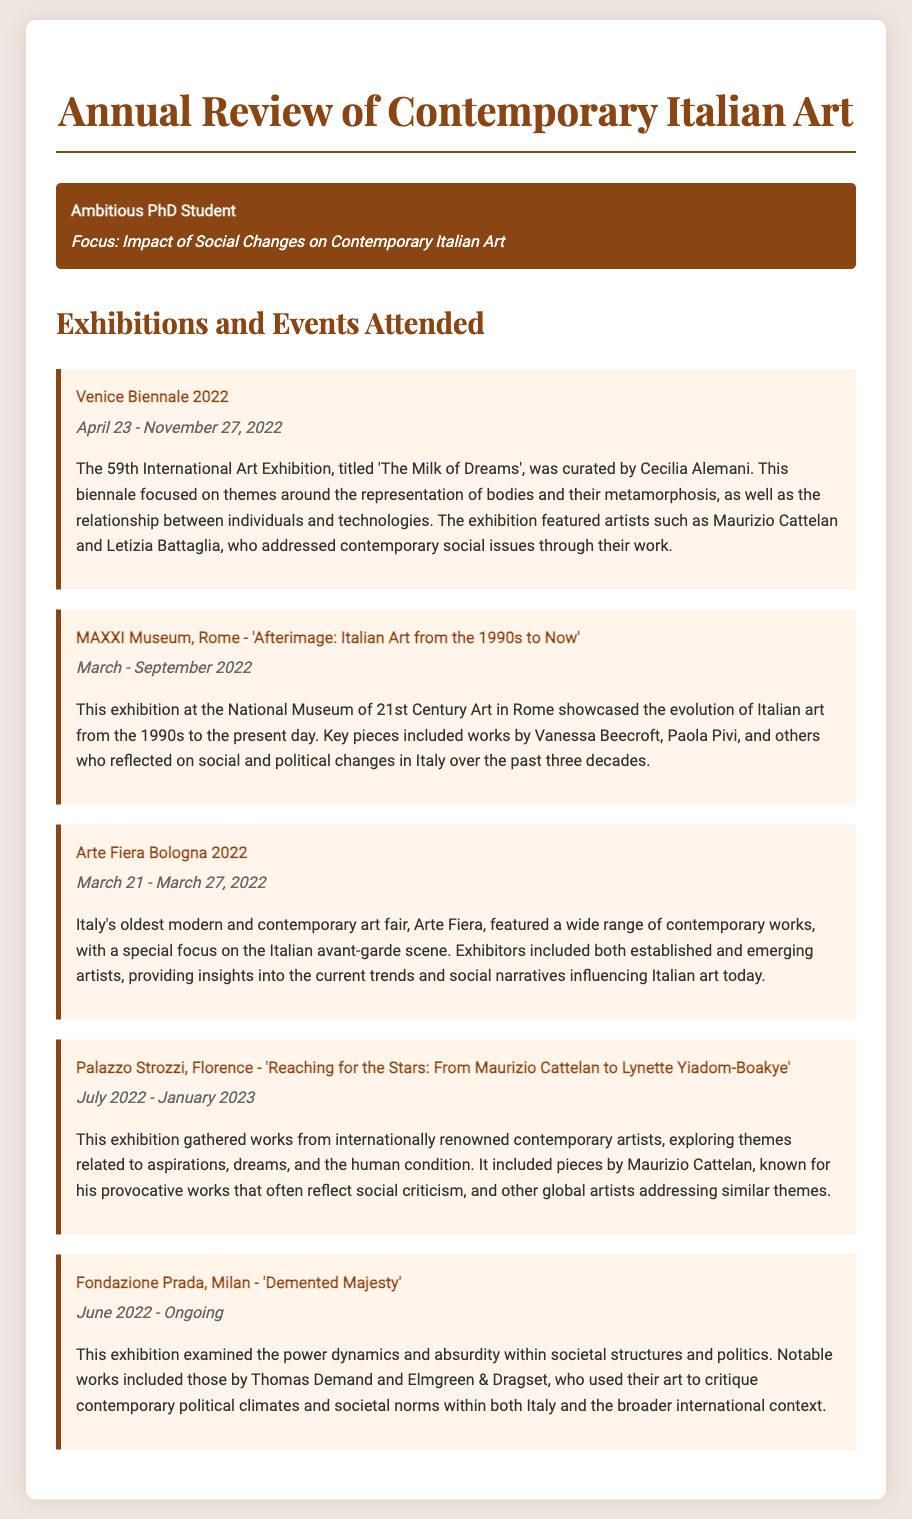What is the title of the Venice Biennale 2022? The title of the Venice Biennale 2022 is 'The Milk of Dreams'.
Answer: 'The Milk of Dreams' Who curated the Venice Biennale 2022? The curator of the Venice Biennale 2022 was Cecilia Alemani.
Answer: Cecilia Alemani In what year did the MAXXI Museum's exhibition 'Afterimage: Italian Art from the 1990s to Now' take place? The exhibition at the MAXXI Museum took place in 2022.
Answer: 2022 What is the date range for the Arte Fiera Bologna 2022? The date range for the Arte Fiera Bologna 2022 is March 21 - March 27, 2022.
Answer: March 21 - March 27, 2022 Which two artists are mentioned in the Palazzo Strozzi exhibition? The artists mentioned in the Palazzo Strozzi exhibition are Maurizio Cattelan and Lynette Yiadom-Boakye.
Answer: Maurizio Cattelan and Lynette Yiadom-Boakye What is a common theme explored in the exhibitions attended? A common theme explored is the relationship between art and social issues.
Answer: Relationship between art and social issues What institution hosted the exhibition 'Demented Majesty'? The exhibition 'Demented Majesty' was hosted by the Fondazione Prada.
Answer: Fondazione Prada What are the dates of the Palazzo Strozzi exhibition? The dates for the Palazzo Strozzi exhibition are July 2022 - January 2023.
Answer: July 2022 - January 2023 What does the 'Demented Majesty' exhibition critique? The 'Demented Majesty' exhibition critiques power dynamics and societal structures.
Answer: Power dynamics and societal structures 